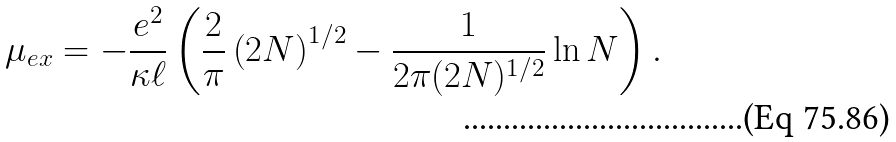Convert formula to latex. <formula><loc_0><loc_0><loc_500><loc_500>\mu _ { e x } = - \frac { e ^ { 2 } } { \kappa \ell } \left ( \frac { 2 } { \pi } \left ( 2 N \right ) ^ { 1 / 2 } - \frac { 1 } { 2 \pi ( 2 N ) ^ { 1 / 2 } } \ln N \right ) .</formula> 